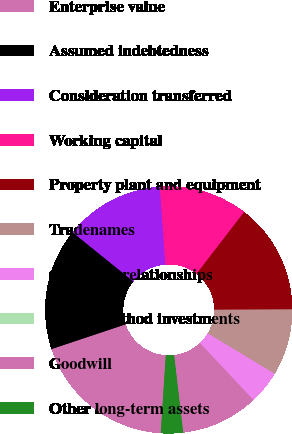Convert chart to OTSL. <chart><loc_0><loc_0><loc_500><loc_500><pie_chart><fcel>Enterprise value<fcel>Assumed indebtedness<fcel>Consideration transferred<fcel>Working capital<fcel>Property plant and equipment<fcel>Tradenames<fcel>Customer relationships<fcel>Equity method investments<fcel>Goodwill<fcel>Other long-term assets<nl><fcel>18.84%<fcel>15.94%<fcel>13.04%<fcel>11.59%<fcel>14.49%<fcel>8.7%<fcel>4.35%<fcel>0.0%<fcel>10.14%<fcel>2.9%<nl></chart> 